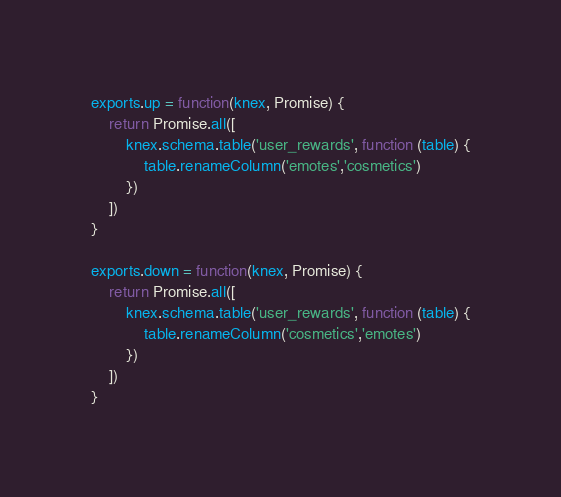Convert code to text. <code><loc_0><loc_0><loc_500><loc_500><_JavaScript_>
exports.up = function(knex, Promise) {
	return Promise.all([
		knex.schema.table('user_rewards', function (table) {
			table.renameColumn('emotes','cosmetics')
		})
	])
}

exports.down = function(knex, Promise) {
	return Promise.all([
		knex.schema.table('user_rewards', function (table) {
			table.renameColumn('cosmetics','emotes')
		})
	])
}
</code> 